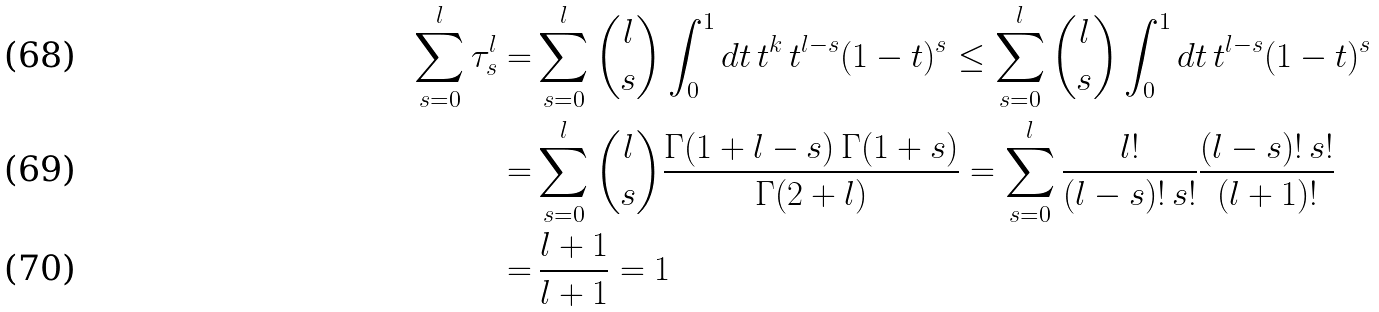<formula> <loc_0><loc_0><loc_500><loc_500>\sum _ { s = 0 } ^ { l } \tau ^ { l } _ { s } = & \sum _ { s = 0 } ^ { l } \binom { l } { s } \int _ { 0 } ^ { 1 } d t \, t ^ { k } \, t ^ { l - s } ( 1 - t ) ^ { s } \leq \sum _ { s = 0 } ^ { l } \binom { l } { s } \int _ { 0 } ^ { 1 } d t \, t ^ { l - s } ( 1 - t ) ^ { s } \\ = & \sum _ { s = 0 } ^ { l } \binom { l } { s } \frac { \Gamma ( 1 + l - s ) \, \Gamma ( 1 + s ) } { \Gamma ( 2 + l ) } = \sum _ { s = 0 } ^ { l } \frac { l ! } { ( l - s ) ! \, s ! } \frac { ( l - s ) ! \, s ! } { ( l + 1 ) ! } \\ = & \, \frac { l + 1 } { l + 1 } = 1</formula> 